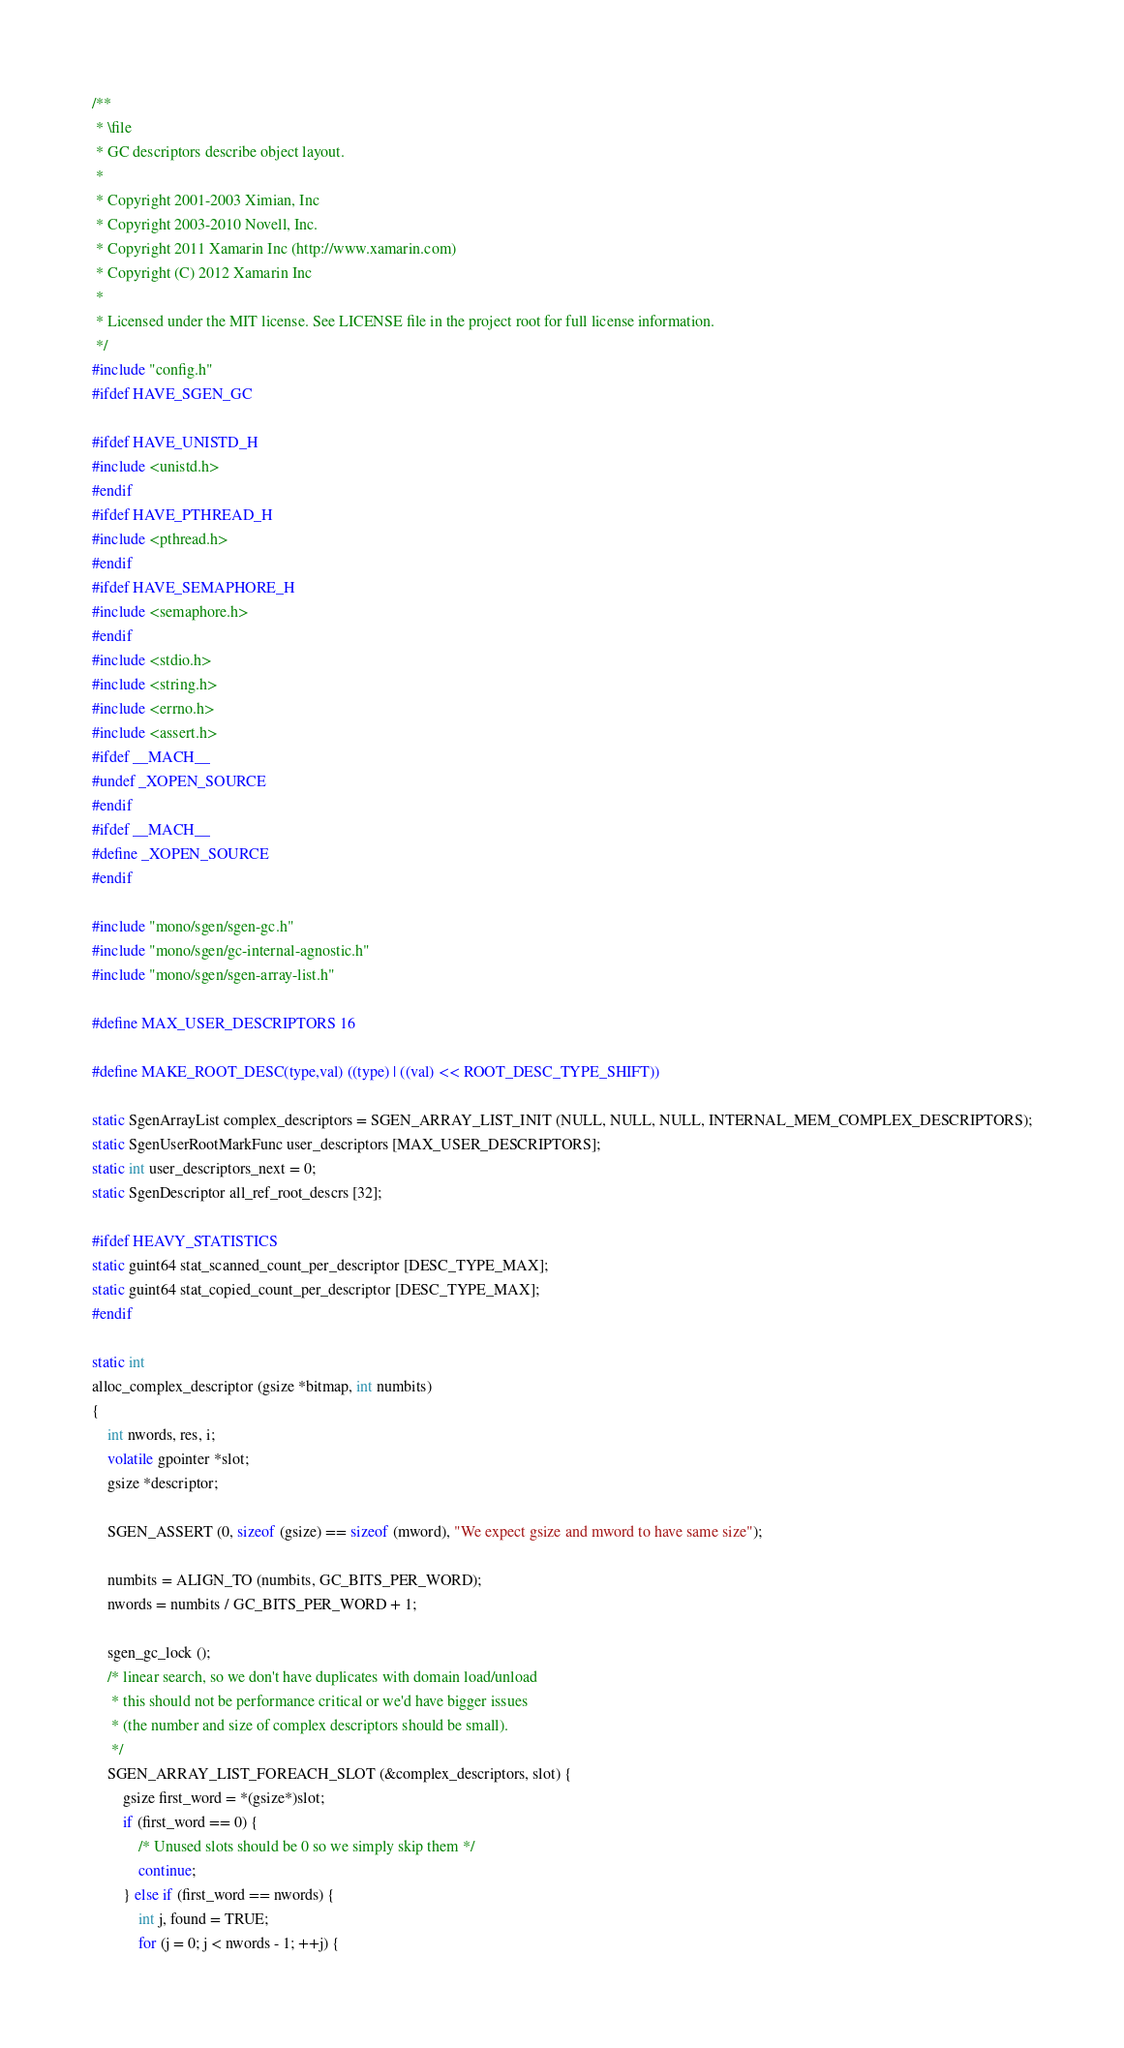Convert code to text. <code><loc_0><loc_0><loc_500><loc_500><_C_>/**
 * \file
 * GC descriptors describe object layout.
 *
 * Copyright 2001-2003 Ximian, Inc
 * Copyright 2003-2010 Novell, Inc.
 * Copyright 2011 Xamarin Inc (http://www.xamarin.com)
 * Copyright (C) 2012 Xamarin Inc
 *
 * Licensed under the MIT license. See LICENSE file in the project root for full license information.
 */
#include "config.h"
#ifdef HAVE_SGEN_GC

#ifdef HAVE_UNISTD_H
#include <unistd.h>
#endif
#ifdef HAVE_PTHREAD_H
#include <pthread.h>
#endif
#ifdef HAVE_SEMAPHORE_H
#include <semaphore.h>
#endif
#include <stdio.h>
#include <string.h>
#include <errno.h>
#include <assert.h>
#ifdef __MACH__
#undef _XOPEN_SOURCE
#endif
#ifdef __MACH__
#define _XOPEN_SOURCE
#endif

#include "mono/sgen/sgen-gc.h"
#include "mono/sgen/gc-internal-agnostic.h"
#include "mono/sgen/sgen-array-list.h"

#define MAX_USER_DESCRIPTORS 16

#define MAKE_ROOT_DESC(type,val) ((type) | ((val) << ROOT_DESC_TYPE_SHIFT))

static SgenArrayList complex_descriptors = SGEN_ARRAY_LIST_INIT (NULL, NULL, NULL, INTERNAL_MEM_COMPLEX_DESCRIPTORS);
static SgenUserRootMarkFunc user_descriptors [MAX_USER_DESCRIPTORS];
static int user_descriptors_next = 0;
static SgenDescriptor all_ref_root_descrs [32];

#ifdef HEAVY_STATISTICS
static guint64 stat_scanned_count_per_descriptor [DESC_TYPE_MAX];
static guint64 stat_copied_count_per_descriptor [DESC_TYPE_MAX];
#endif

static int
alloc_complex_descriptor (gsize *bitmap, int numbits)
{
	int nwords, res, i;
	volatile gpointer *slot;
	gsize *descriptor;

	SGEN_ASSERT (0, sizeof (gsize) == sizeof (mword), "We expect gsize and mword to have same size");

	numbits = ALIGN_TO (numbits, GC_BITS_PER_WORD);
	nwords = numbits / GC_BITS_PER_WORD + 1;

	sgen_gc_lock ();
	/* linear search, so we don't have duplicates with domain load/unload
	 * this should not be performance critical or we'd have bigger issues
	 * (the number and size of complex descriptors should be small).
	 */
	SGEN_ARRAY_LIST_FOREACH_SLOT (&complex_descriptors, slot) {
		gsize first_word = *(gsize*)slot;
		if (first_word == 0) {
			/* Unused slots should be 0 so we simply skip them */
			continue;
		} else if (first_word == nwords) {
			int j, found = TRUE;
			for (j = 0; j < nwords - 1; ++j) {</code> 